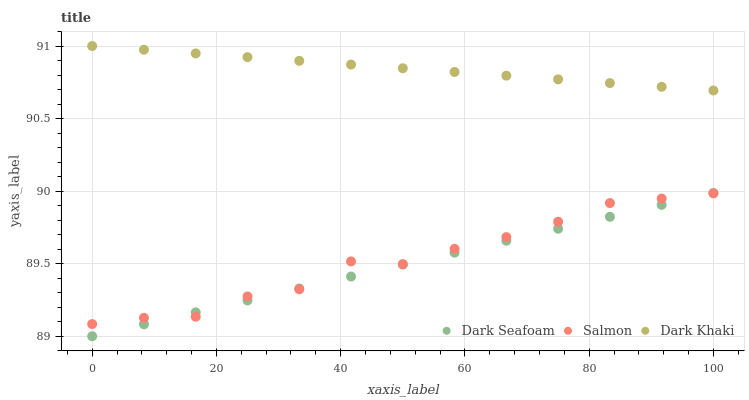Does Dark Seafoam have the minimum area under the curve?
Answer yes or no. Yes. Does Dark Khaki have the maximum area under the curve?
Answer yes or no. Yes. Does Salmon have the minimum area under the curve?
Answer yes or no. No. Does Salmon have the maximum area under the curve?
Answer yes or no. No. Is Dark Seafoam the smoothest?
Answer yes or no. Yes. Is Salmon the roughest?
Answer yes or no. Yes. Is Salmon the smoothest?
Answer yes or no. No. Is Dark Seafoam the roughest?
Answer yes or no. No. Does Dark Seafoam have the lowest value?
Answer yes or no. Yes. Does Salmon have the lowest value?
Answer yes or no. No. Does Dark Khaki have the highest value?
Answer yes or no. Yes. Does Dark Seafoam have the highest value?
Answer yes or no. No. Is Dark Seafoam less than Dark Khaki?
Answer yes or no. Yes. Is Dark Khaki greater than Salmon?
Answer yes or no. Yes. Does Salmon intersect Dark Seafoam?
Answer yes or no. Yes. Is Salmon less than Dark Seafoam?
Answer yes or no. No. Is Salmon greater than Dark Seafoam?
Answer yes or no. No. Does Dark Seafoam intersect Dark Khaki?
Answer yes or no. No. 